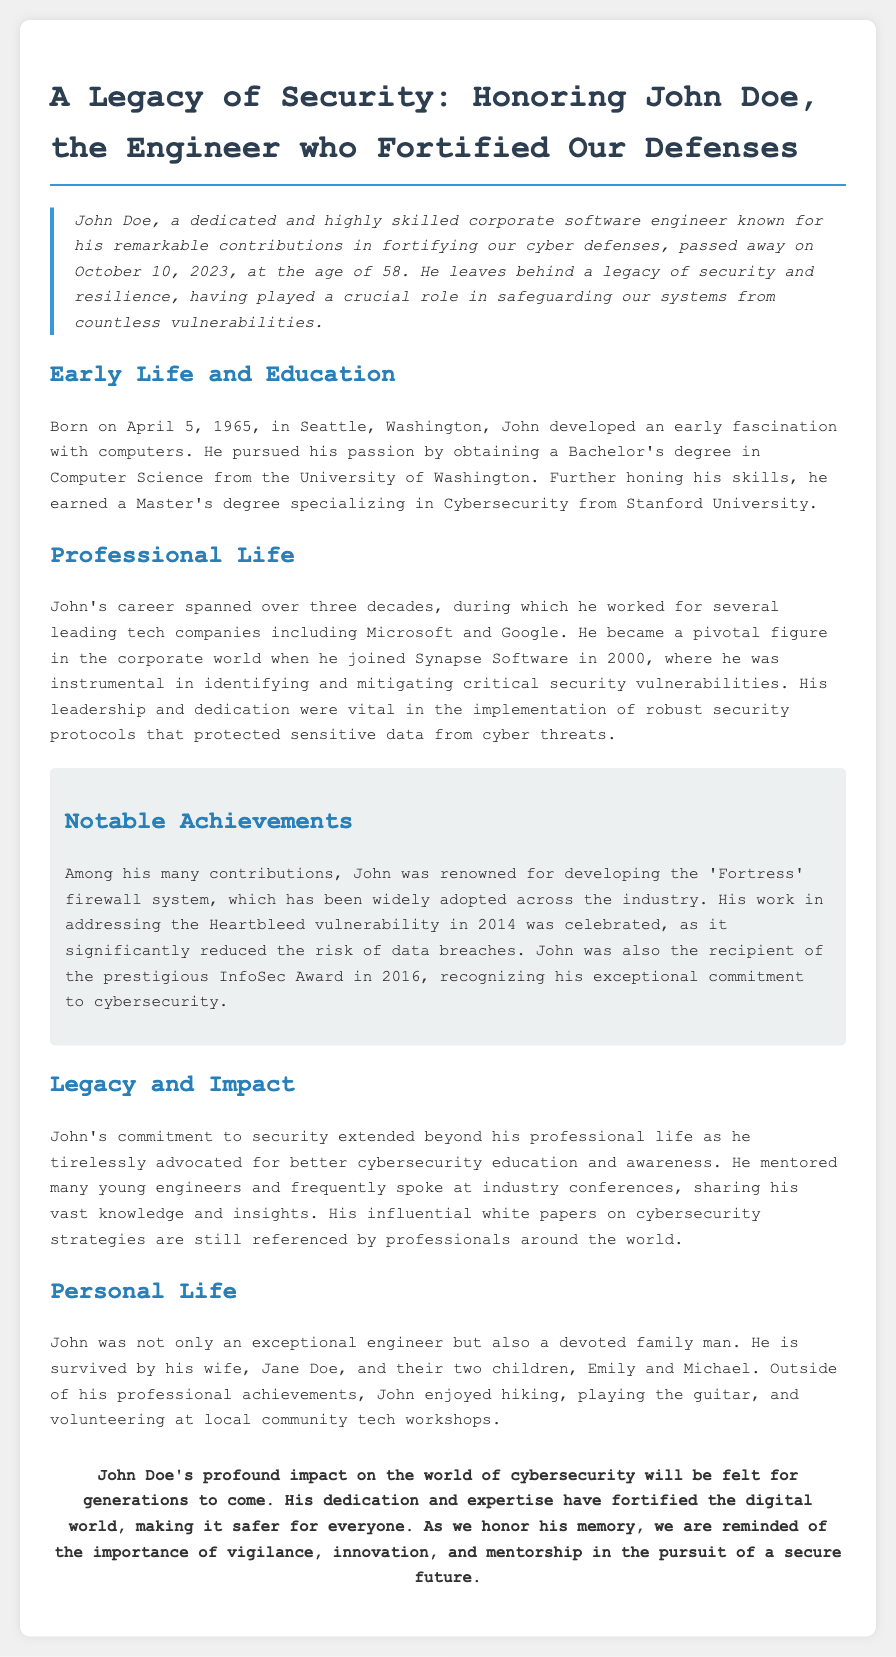What was John Doe's age at the time of his passing? John Doe passed away at the age of 58, as mentioned in the introduction.
Answer: 58 When did John Doe pass away? The document states that John Doe passed away on October 10, 2023.
Answer: October 10, 2023 What degree did John earn from Stanford University? It is specified in the document that he earned a Master's degree specializing in Cybersecurity from Stanford University.
Answer: Master's degree in Cybersecurity Which company did John Doe join in 2000? The document notes that John joined Synapse Software in 2000.
Answer: Synapse Software What is the name of the firewall system developed by John Doe? The document highlights that John was renowned for developing the 'Fortress' firewall system.
Answer: Fortress How many children did John Doe have? The document mentions that John is survived by two children.
Answer: Two What was a significant contribution John made in 2014? The document states that he worked on addressing the Heartbleed vulnerability in 2014, which was a significant contribution.
Answer: Heartbleed vulnerability What role did John play in cybersecurity education? The document explains that John advocated for better cybersecurity education and mentored many young engineers.
Answer: Advocated for better cybersecurity education What was a personal hobby of John Doe? According to the personal life section, John enjoyed playing the guitar outside of his professional achievements.
Answer: Playing the guitar 